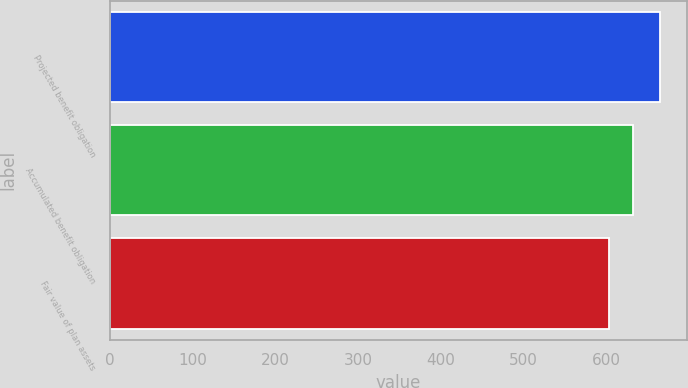<chart> <loc_0><loc_0><loc_500><loc_500><bar_chart><fcel>Projected benefit obligation<fcel>Accumulated benefit obligation<fcel>Fair value of plan assets<nl><fcel>665<fcel>633<fcel>604<nl></chart> 